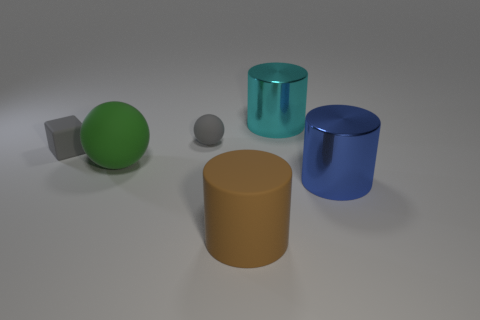How many objects are in front of the blue metallic cylinder?
Offer a terse response. 1. There is a thing in front of the big shiny cylinder in front of the big matte thing that is on the left side of the rubber cylinder; what size is it?
Your answer should be compact. Large. Are there any small gray balls on the left side of the small gray matte thing that is on the left side of the rubber sphere that is right of the big green rubber thing?
Offer a very short reply. No. Are there more large things than large brown rubber things?
Your answer should be very brief. Yes. What is the color of the big object to the left of the brown thing?
Offer a terse response. Green. Are there more things to the left of the blue cylinder than large yellow rubber cubes?
Make the answer very short. Yes. Is the material of the brown cylinder the same as the gray cube?
Ensure brevity in your answer.  Yes. What number of other things are there of the same shape as the big green rubber object?
Make the answer very short. 1. Is there anything else that is the same material as the big blue cylinder?
Offer a terse response. Yes. There is a big shiny thing that is in front of the large matte thing behind the large cylinder that is in front of the blue cylinder; what is its color?
Your answer should be compact. Blue. 